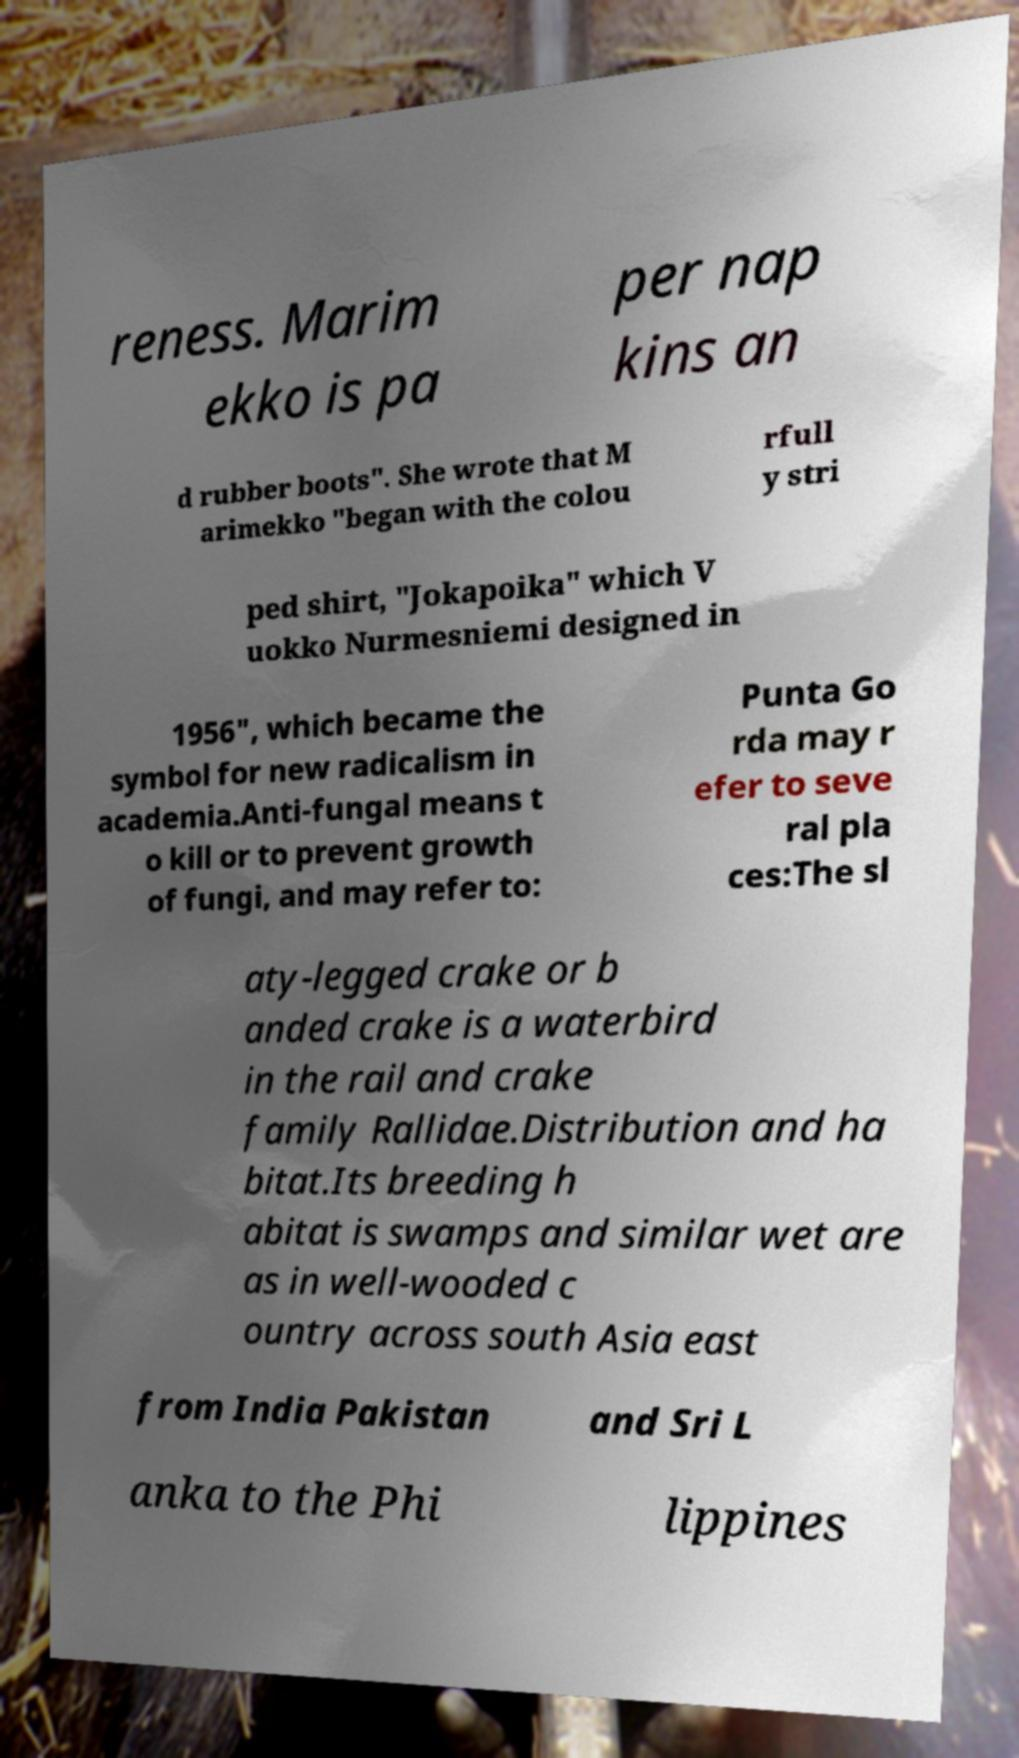What messages or text are displayed in this image? I need them in a readable, typed format. reness. Marim ekko is pa per nap kins an d rubber boots". She wrote that M arimekko "began with the colou rfull y stri ped shirt, "Jokapoika" which V uokko Nurmesniemi designed in 1956", which became the symbol for new radicalism in academia.Anti-fungal means t o kill or to prevent growth of fungi, and may refer to: Punta Go rda may r efer to seve ral pla ces:The sl aty-legged crake or b anded crake is a waterbird in the rail and crake family Rallidae.Distribution and ha bitat.Its breeding h abitat is swamps and similar wet are as in well-wooded c ountry across south Asia east from India Pakistan and Sri L anka to the Phi lippines 